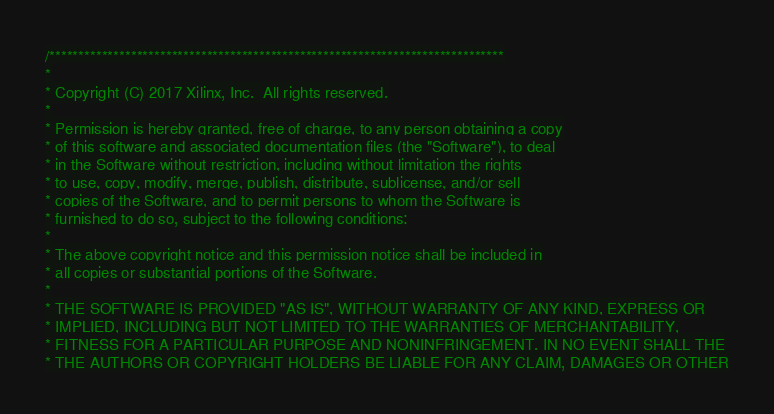Convert code to text. <code><loc_0><loc_0><loc_500><loc_500><_C_>/******************************************************************************
*
* Copyright (C) 2017 Xilinx, Inc.  All rights reserved.
*
* Permission is hereby granted, free of charge, to any person obtaining a copy
* of this software and associated documentation files (the "Software"), to deal
* in the Software without restriction, including without limitation the rights
* to use, copy, modify, merge, publish, distribute, sublicense, and/or sell
* copies of the Software, and to permit persons to whom the Software is
* furnished to do so, subject to the following conditions:
*
* The above copyright notice and this permission notice shall be included in
* all copies or substantial portions of the Software.
*
* THE SOFTWARE IS PROVIDED "AS IS", WITHOUT WARRANTY OF ANY KIND, EXPRESS OR
* IMPLIED, INCLUDING BUT NOT LIMITED TO THE WARRANTIES OF MERCHANTABILITY,
* FITNESS FOR A PARTICULAR PURPOSE AND NONINFRINGEMENT. IN NO EVENT SHALL THE
* THE AUTHORS OR COPYRIGHT HOLDERS BE LIABLE FOR ANY CLAIM, DAMAGES OR OTHER</code> 